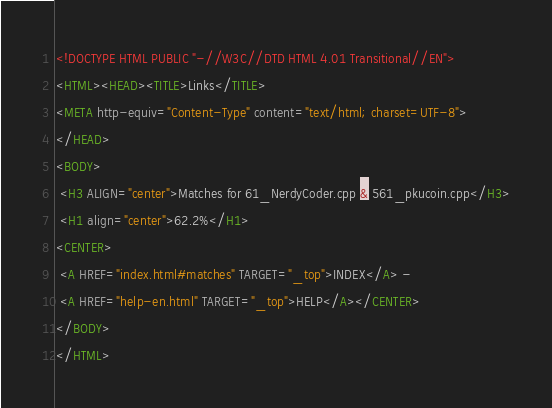<code> <loc_0><loc_0><loc_500><loc_500><_HTML_><!DOCTYPE HTML PUBLIC "-//W3C//DTD HTML 4.01 Transitional//EN">
<HTML><HEAD><TITLE>Links</TITLE>
<META http-equiv="Content-Type" content="text/html; charset=UTF-8">
</HEAD>
<BODY>
 <H3 ALIGN="center">Matches for 61_NerdyCoder.cpp & 561_pkucoin.cpp</H3>
 <H1 align="center">62.2%</H1>
<CENTER>
 <A HREF="index.html#matches" TARGET="_top">INDEX</A> - 
 <A HREF="help-en.html" TARGET="_top">HELP</A></CENTER>
</BODY>
</HTML>
</code> 